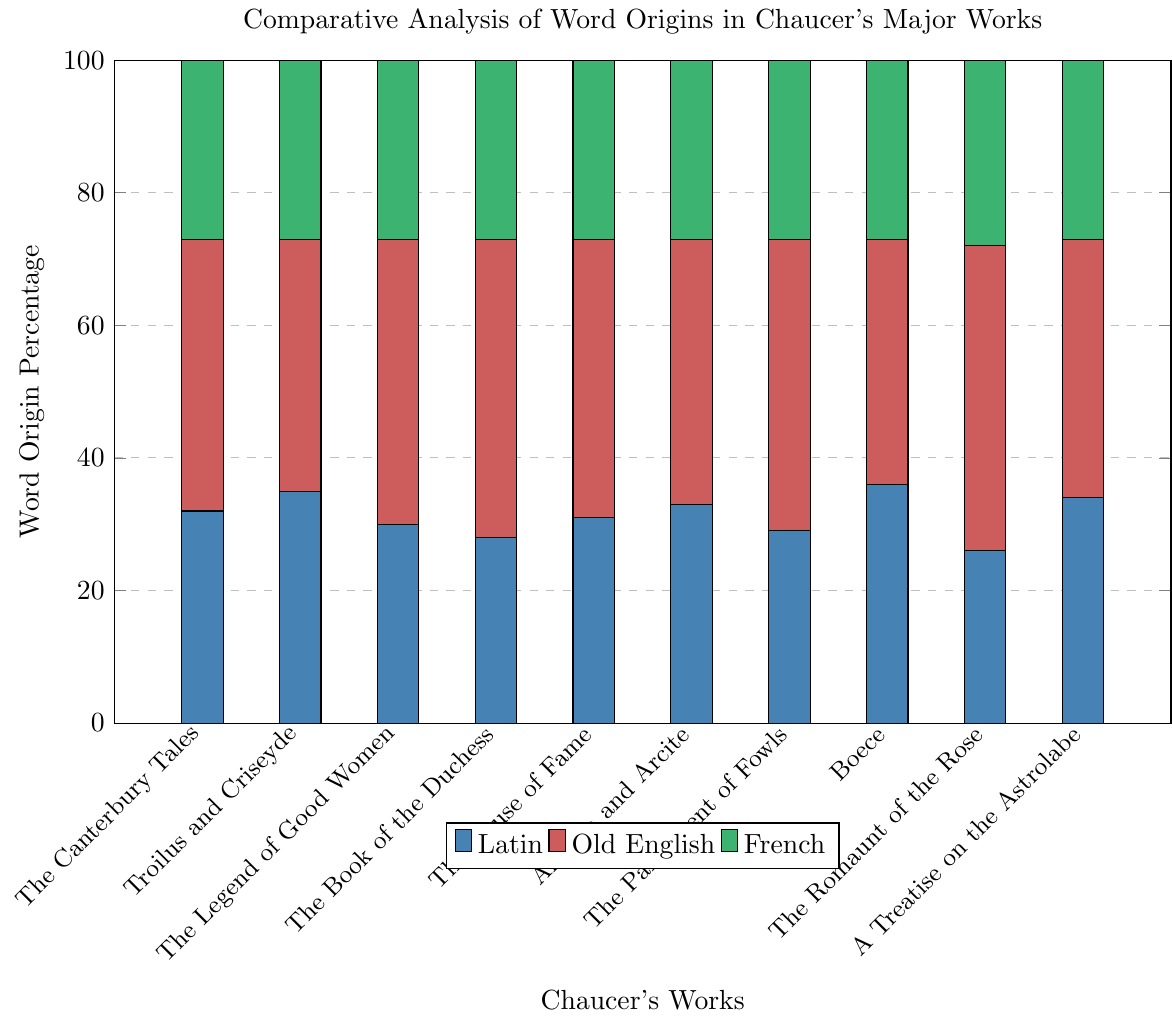Which work has the highest percentage of Latin word origins? The highest bar for Latin percentages is observed in "Boece" at 36%.
Answer: Boece Which works have the same percentage of French word origins? By observing the green sections of the stacked bars, it is evident that all works except "The Romaunt of the Rose" have a French origin percentage of 27%.
Answer: All except The Romaunt of the Rose What is the average percentage of Old English word origins across all works? The percentages of Old English word origins are summed up as 41 + 38 + 43 + 45 + 42 + 40 + 44 + 37 + 46 + 39 = 415. The average is calculated as 415 / 10 = 41.5%.
Answer: 41.5% How many works have a higher percentage of Old English than Latin word origins? By comparing the bars for Old English (red) and Latin (blue) in each stacked bar, it is clear that all works have a higher percentage of Old English than Latin word origins.
Answer: 10 Which work has the lowest percentage of Latin word origins? The shortest blue section in the bars is in "The Romaunt of the Rose" with 26%.
Answer: The Romaunt of the Rose Is there any work with an equal percentage of Latin and French word origins? By observing the stacked bars, no work has equal percentages of Latin (blue) and French (green) word origins.
Answer: No Which work has the second highest usage of French word origins? The second tallest green bar is for "The Romaunt of the Rose" at 28%. The other works all have 27% for French word origins.
Answer: The Romaunt of the Rose 